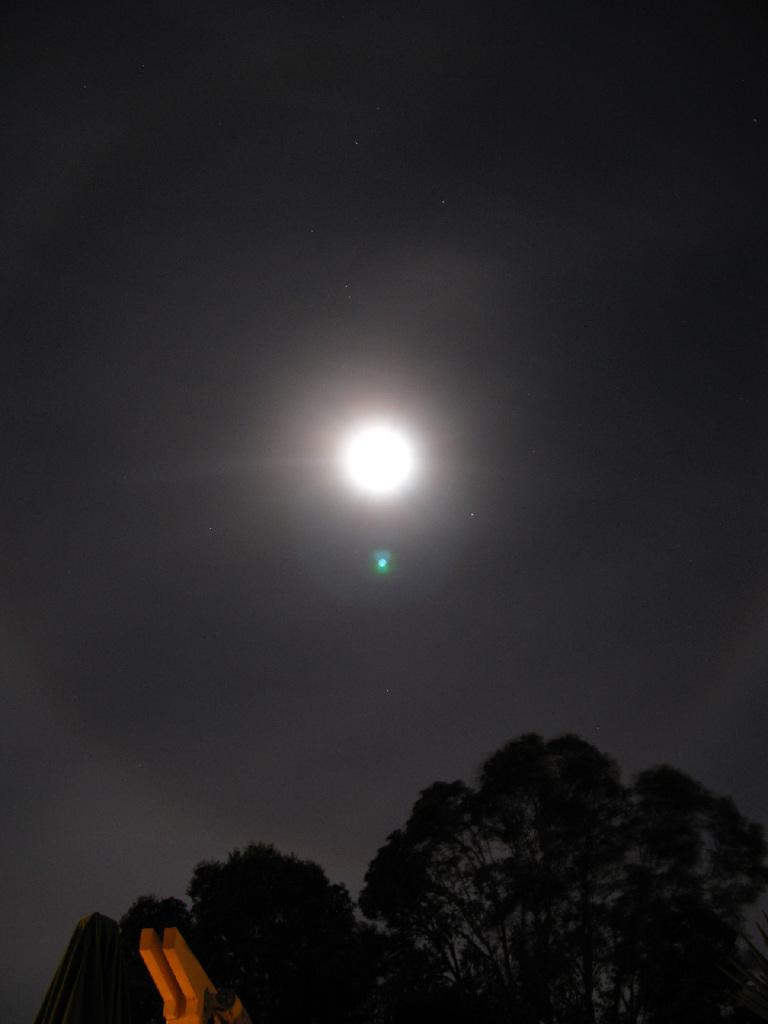What type of vegetation can be seen in the image? There are trees in the image. What is visible at the top of the image? The sky is visible at the top of the image. Can you describe the celestial body in the sky? There is a moon in the sky. What can be found at the bottom left of the image? There are objects at the bottom left of the image. What sound does the boy make while playing with the chance in the image? There is no boy or chance present in the image. What type of chance is depicted in the image? There is no chance depicted in the image. 